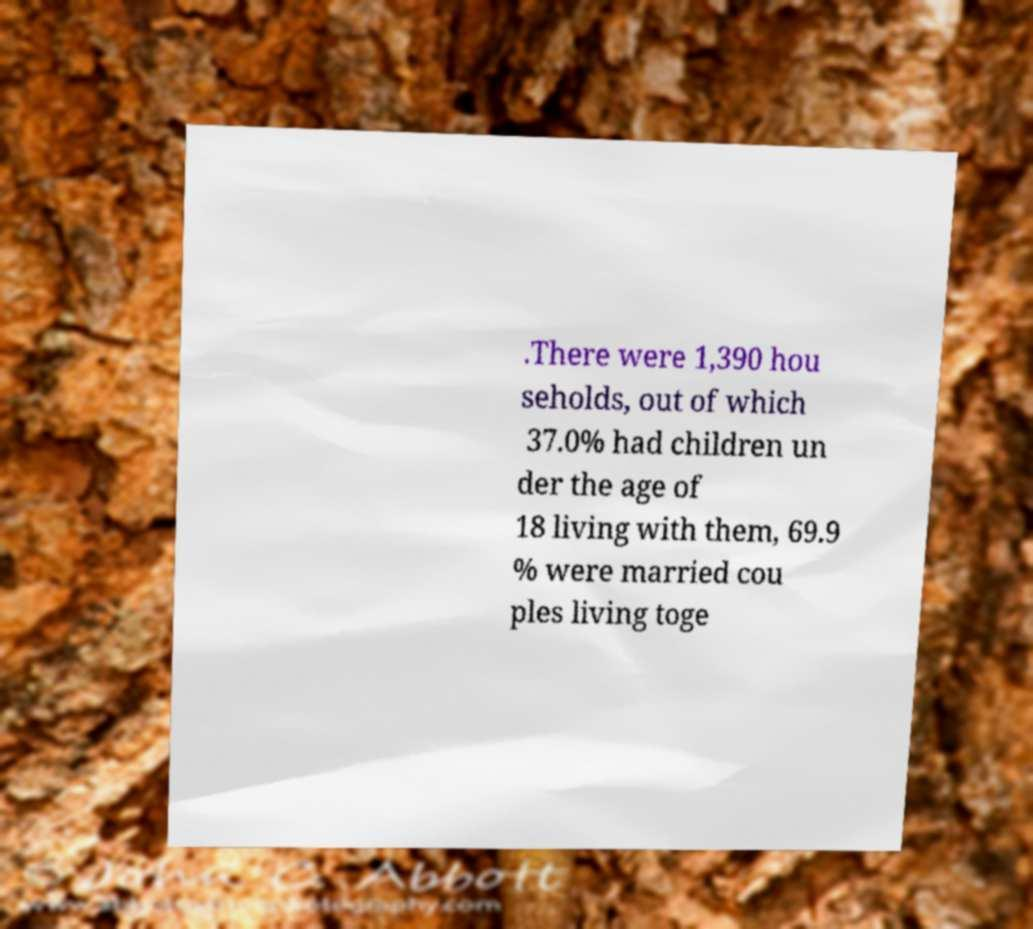Can you accurately transcribe the text from the provided image for me? .There were 1,390 hou seholds, out of which 37.0% had children un der the age of 18 living with them, 69.9 % were married cou ples living toge 